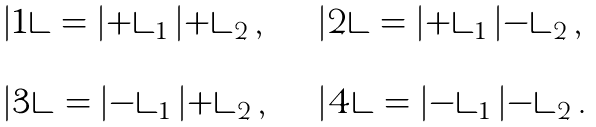<formula> <loc_0><loc_0><loc_500><loc_500>\begin{array} { l l } | 1 \rangle = | + \rangle _ { 1 } \, | + \rangle _ { 2 } \, , & \quad | 2 \rangle = | + \rangle _ { 1 } \, | - \rangle _ { 2 } \, , \\ & \\ | 3 \rangle = | - \rangle _ { 1 } \, | + \rangle _ { 2 } \, , & \quad | 4 \rangle = | - \rangle _ { 1 } \, | - \rangle _ { 2 } \, . \end{array}</formula> 